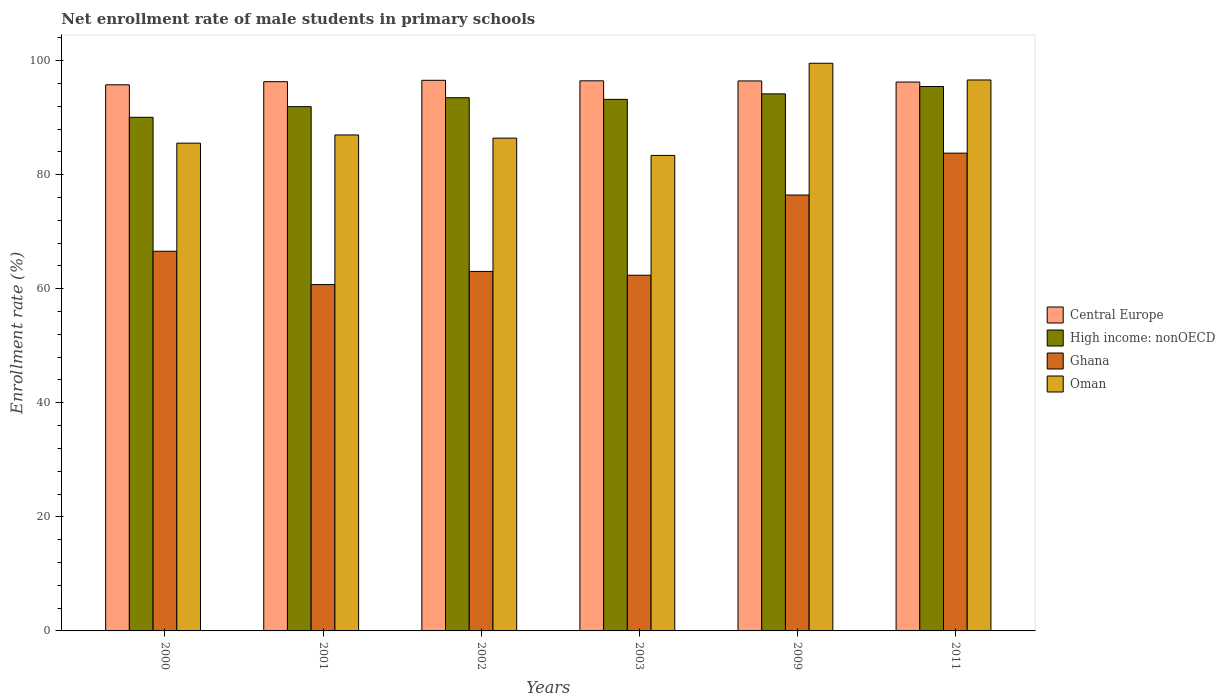How many groups of bars are there?
Your answer should be very brief. 6. How many bars are there on the 3rd tick from the left?
Make the answer very short. 4. How many bars are there on the 3rd tick from the right?
Your answer should be very brief. 4. What is the label of the 4th group of bars from the left?
Your answer should be very brief. 2003. In how many cases, is the number of bars for a given year not equal to the number of legend labels?
Provide a succinct answer. 0. What is the net enrollment rate of male students in primary schools in Central Europe in 2002?
Your answer should be compact. 96.54. Across all years, what is the maximum net enrollment rate of male students in primary schools in High income: nonOECD?
Ensure brevity in your answer.  95.45. Across all years, what is the minimum net enrollment rate of male students in primary schools in Ghana?
Your answer should be compact. 60.73. In which year was the net enrollment rate of male students in primary schools in Central Europe maximum?
Offer a very short reply. 2002. In which year was the net enrollment rate of male students in primary schools in Oman minimum?
Your answer should be compact. 2003. What is the total net enrollment rate of male students in primary schools in Central Europe in the graph?
Your response must be concise. 577.73. What is the difference between the net enrollment rate of male students in primary schools in Oman in 2002 and that in 2009?
Give a very brief answer. -13.13. What is the difference between the net enrollment rate of male students in primary schools in Oman in 2011 and the net enrollment rate of male students in primary schools in High income: nonOECD in 2009?
Offer a very short reply. 2.44. What is the average net enrollment rate of male students in primary schools in Central Europe per year?
Provide a succinct answer. 96.29. In the year 2000, what is the difference between the net enrollment rate of male students in primary schools in Central Europe and net enrollment rate of male students in primary schools in High income: nonOECD?
Offer a very short reply. 5.7. What is the ratio of the net enrollment rate of male students in primary schools in Central Europe in 2002 to that in 2009?
Ensure brevity in your answer.  1. Is the net enrollment rate of male students in primary schools in High income: nonOECD in 2002 less than that in 2003?
Make the answer very short. No. What is the difference between the highest and the second highest net enrollment rate of male students in primary schools in Ghana?
Provide a succinct answer. 7.34. What is the difference between the highest and the lowest net enrollment rate of male students in primary schools in Oman?
Provide a short and direct response. 16.16. Is the sum of the net enrollment rate of male students in primary schools in Central Europe in 2009 and 2011 greater than the maximum net enrollment rate of male students in primary schools in Oman across all years?
Offer a terse response. Yes. What does the 2nd bar from the left in 2003 represents?
Provide a short and direct response. High income: nonOECD. What does the 3rd bar from the right in 2002 represents?
Offer a very short reply. High income: nonOECD. Is it the case that in every year, the sum of the net enrollment rate of male students in primary schools in Oman and net enrollment rate of male students in primary schools in Central Europe is greater than the net enrollment rate of male students in primary schools in High income: nonOECD?
Your answer should be compact. Yes. How many bars are there?
Offer a terse response. 24. Where does the legend appear in the graph?
Ensure brevity in your answer.  Center right. How are the legend labels stacked?
Make the answer very short. Vertical. What is the title of the graph?
Offer a terse response. Net enrollment rate of male students in primary schools. What is the label or title of the Y-axis?
Keep it short and to the point. Enrollment rate (%). What is the Enrollment rate (%) of Central Europe in 2000?
Offer a very short reply. 95.75. What is the Enrollment rate (%) of High income: nonOECD in 2000?
Provide a short and direct response. 90.06. What is the Enrollment rate (%) in Ghana in 2000?
Ensure brevity in your answer.  66.57. What is the Enrollment rate (%) of Oman in 2000?
Offer a very short reply. 85.52. What is the Enrollment rate (%) of Central Europe in 2001?
Your answer should be very brief. 96.3. What is the Enrollment rate (%) of High income: nonOECD in 2001?
Offer a very short reply. 91.92. What is the Enrollment rate (%) in Ghana in 2001?
Keep it short and to the point. 60.73. What is the Enrollment rate (%) of Oman in 2001?
Your answer should be very brief. 86.96. What is the Enrollment rate (%) of Central Europe in 2002?
Offer a very short reply. 96.54. What is the Enrollment rate (%) of High income: nonOECD in 2002?
Your answer should be very brief. 93.49. What is the Enrollment rate (%) in Ghana in 2002?
Provide a short and direct response. 63.04. What is the Enrollment rate (%) of Oman in 2002?
Keep it short and to the point. 86.4. What is the Enrollment rate (%) of Central Europe in 2003?
Keep it short and to the point. 96.46. What is the Enrollment rate (%) of High income: nonOECD in 2003?
Offer a very short reply. 93.2. What is the Enrollment rate (%) of Ghana in 2003?
Provide a succinct answer. 62.37. What is the Enrollment rate (%) in Oman in 2003?
Your answer should be compact. 83.37. What is the Enrollment rate (%) in Central Europe in 2009?
Your answer should be very brief. 96.43. What is the Enrollment rate (%) in High income: nonOECD in 2009?
Your answer should be very brief. 94.17. What is the Enrollment rate (%) in Ghana in 2009?
Ensure brevity in your answer.  76.43. What is the Enrollment rate (%) in Oman in 2009?
Give a very brief answer. 99.53. What is the Enrollment rate (%) in Central Europe in 2011?
Provide a short and direct response. 96.24. What is the Enrollment rate (%) of High income: nonOECD in 2011?
Make the answer very short. 95.45. What is the Enrollment rate (%) of Ghana in 2011?
Offer a very short reply. 83.77. What is the Enrollment rate (%) of Oman in 2011?
Provide a succinct answer. 96.6. Across all years, what is the maximum Enrollment rate (%) of Central Europe?
Ensure brevity in your answer.  96.54. Across all years, what is the maximum Enrollment rate (%) in High income: nonOECD?
Your response must be concise. 95.45. Across all years, what is the maximum Enrollment rate (%) in Ghana?
Ensure brevity in your answer.  83.77. Across all years, what is the maximum Enrollment rate (%) of Oman?
Offer a very short reply. 99.53. Across all years, what is the minimum Enrollment rate (%) of Central Europe?
Keep it short and to the point. 95.75. Across all years, what is the minimum Enrollment rate (%) in High income: nonOECD?
Your answer should be very brief. 90.06. Across all years, what is the minimum Enrollment rate (%) of Ghana?
Ensure brevity in your answer.  60.73. Across all years, what is the minimum Enrollment rate (%) in Oman?
Your answer should be compact. 83.37. What is the total Enrollment rate (%) of Central Europe in the graph?
Give a very brief answer. 577.73. What is the total Enrollment rate (%) in High income: nonOECD in the graph?
Provide a short and direct response. 558.28. What is the total Enrollment rate (%) of Ghana in the graph?
Make the answer very short. 412.9. What is the total Enrollment rate (%) in Oman in the graph?
Provide a succinct answer. 538.39. What is the difference between the Enrollment rate (%) of Central Europe in 2000 and that in 2001?
Provide a short and direct response. -0.55. What is the difference between the Enrollment rate (%) of High income: nonOECD in 2000 and that in 2001?
Make the answer very short. -1.86. What is the difference between the Enrollment rate (%) in Ghana in 2000 and that in 2001?
Your response must be concise. 5.84. What is the difference between the Enrollment rate (%) of Oman in 2000 and that in 2001?
Your answer should be very brief. -1.44. What is the difference between the Enrollment rate (%) in Central Europe in 2000 and that in 2002?
Provide a short and direct response. -0.79. What is the difference between the Enrollment rate (%) of High income: nonOECD in 2000 and that in 2002?
Your response must be concise. -3.43. What is the difference between the Enrollment rate (%) in Ghana in 2000 and that in 2002?
Offer a very short reply. 3.53. What is the difference between the Enrollment rate (%) of Oman in 2000 and that in 2002?
Your answer should be compact. -0.88. What is the difference between the Enrollment rate (%) of Central Europe in 2000 and that in 2003?
Provide a short and direct response. -0.7. What is the difference between the Enrollment rate (%) in High income: nonOECD in 2000 and that in 2003?
Your response must be concise. -3.14. What is the difference between the Enrollment rate (%) in Ghana in 2000 and that in 2003?
Provide a short and direct response. 4.2. What is the difference between the Enrollment rate (%) in Oman in 2000 and that in 2003?
Your answer should be very brief. 2.15. What is the difference between the Enrollment rate (%) of Central Europe in 2000 and that in 2009?
Give a very brief answer. -0.68. What is the difference between the Enrollment rate (%) of High income: nonOECD in 2000 and that in 2009?
Offer a terse response. -4.11. What is the difference between the Enrollment rate (%) of Ghana in 2000 and that in 2009?
Give a very brief answer. -9.86. What is the difference between the Enrollment rate (%) of Oman in 2000 and that in 2009?
Keep it short and to the point. -14.01. What is the difference between the Enrollment rate (%) of Central Europe in 2000 and that in 2011?
Give a very brief answer. -0.49. What is the difference between the Enrollment rate (%) in High income: nonOECD in 2000 and that in 2011?
Offer a very short reply. -5.39. What is the difference between the Enrollment rate (%) of Ghana in 2000 and that in 2011?
Keep it short and to the point. -17.2. What is the difference between the Enrollment rate (%) in Oman in 2000 and that in 2011?
Offer a very short reply. -11.08. What is the difference between the Enrollment rate (%) of Central Europe in 2001 and that in 2002?
Provide a short and direct response. -0.24. What is the difference between the Enrollment rate (%) in High income: nonOECD in 2001 and that in 2002?
Make the answer very short. -1.57. What is the difference between the Enrollment rate (%) in Ghana in 2001 and that in 2002?
Make the answer very short. -2.31. What is the difference between the Enrollment rate (%) in Oman in 2001 and that in 2002?
Offer a very short reply. 0.56. What is the difference between the Enrollment rate (%) of Central Europe in 2001 and that in 2003?
Your response must be concise. -0.15. What is the difference between the Enrollment rate (%) in High income: nonOECD in 2001 and that in 2003?
Give a very brief answer. -1.28. What is the difference between the Enrollment rate (%) of Ghana in 2001 and that in 2003?
Offer a terse response. -1.64. What is the difference between the Enrollment rate (%) in Oman in 2001 and that in 2003?
Offer a very short reply. 3.59. What is the difference between the Enrollment rate (%) in Central Europe in 2001 and that in 2009?
Make the answer very short. -0.13. What is the difference between the Enrollment rate (%) of High income: nonOECD in 2001 and that in 2009?
Offer a very short reply. -2.24. What is the difference between the Enrollment rate (%) of Ghana in 2001 and that in 2009?
Your answer should be compact. -15.7. What is the difference between the Enrollment rate (%) of Oman in 2001 and that in 2009?
Offer a terse response. -12.57. What is the difference between the Enrollment rate (%) in Central Europe in 2001 and that in 2011?
Your answer should be compact. 0.06. What is the difference between the Enrollment rate (%) of High income: nonOECD in 2001 and that in 2011?
Your response must be concise. -3.53. What is the difference between the Enrollment rate (%) in Ghana in 2001 and that in 2011?
Your answer should be compact. -23.05. What is the difference between the Enrollment rate (%) of Oman in 2001 and that in 2011?
Ensure brevity in your answer.  -9.64. What is the difference between the Enrollment rate (%) in Central Europe in 2002 and that in 2003?
Keep it short and to the point. 0.09. What is the difference between the Enrollment rate (%) in High income: nonOECD in 2002 and that in 2003?
Offer a terse response. 0.29. What is the difference between the Enrollment rate (%) in Ghana in 2002 and that in 2003?
Ensure brevity in your answer.  0.67. What is the difference between the Enrollment rate (%) in Oman in 2002 and that in 2003?
Offer a terse response. 3.03. What is the difference between the Enrollment rate (%) in Central Europe in 2002 and that in 2009?
Give a very brief answer. 0.11. What is the difference between the Enrollment rate (%) of High income: nonOECD in 2002 and that in 2009?
Offer a very short reply. -0.68. What is the difference between the Enrollment rate (%) of Ghana in 2002 and that in 2009?
Your answer should be very brief. -13.39. What is the difference between the Enrollment rate (%) of Oman in 2002 and that in 2009?
Offer a very short reply. -13.13. What is the difference between the Enrollment rate (%) in Central Europe in 2002 and that in 2011?
Offer a very short reply. 0.3. What is the difference between the Enrollment rate (%) in High income: nonOECD in 2002 and that in 2011?
Your answer should be compact. -1.96. What is the difference between the Enrollment rate (%) in Ghana in 2002 and that in 2011?
Ensure brevity in your answer.  -20.74. What is the difference between the Enrollment rate (%) in Oman in 2002 and that in 2011?
Keep it short and to the point. -10.2. What is the difference between the Enrollment rate (%) in Central Europe in 2003 and that in 2009?
Your answer should be compact. 0.02. What is the difference between the Enrollment rate (%) in High income: nonOECD in 2003 and that in 2009?
Provide a succinct answer. -0.96. What is the difference between the Enrollment rate (%) in Ghana in 2003 and that in 2009?
Your response must be concise. -14.06. What is the difference between the Enrollment rate (%) of Oman in 2003 and that in 2009?
Offer a very short reply. -16.16. What is the difference between the Enrollment rate (%) in Central Europe in 2003 and that in 2011?
Make the answer very short. 0.22. What is the difference between the Enrollment rate (%) in High income: nonOECD in 2003 and that in 2011?
Provide a succinct answer. -2.25. What is the difference between the Enrollment rate (%) of Ghana in 2003 and that in 2011?
Your response must be concise. -21.4. What is the difference between the Enrollment rate (%) of Oman in 2003 and that in 2011?
Offer a very short reply. -13.23. What is the difference between the Enrollment rate (%) in Central Europe in 2009 and that in 2011?
Ensure brevity in your answer.  0.19. What is the difference between the Enrollment rate (%) in High income: nonOECD in 2009 and that in 2011?
Provide a succinct answer. -1.29. What is the difference between the Enrollment rate (%) in Ghana in 2009 and that in 2011?
Offer a terse response. -7.34. What is the difference between the Enrollment rate (%) of Oman in 2009 and that in 2011?
Your answer should be very brief. 2.93. What is the difference between the Enrollment rate (%) of Central Europe in 2000 and the Enrollment rate (%) of High income: nonOECD in 2001?
Offer a terse response. 3.83. What is the difference between the Enrollment rate (%) in Central Europe in 2000 and the Enrollment rate (%) in Ghana in 2001?
Provide a succinct answer. 35.03. What is the difference between the Enrollment rate (%) of Central Europe in 2000 and the Enrollment rate (%) of Oman in 2001?
Give a very brief answer. 8.79. What is the difference between the Enrollment rate (%) in High income: nonOECD in 2000 and the Enrollment rate (%) in Ghana in 2001?
Give a very brief answer. 29.33. What is the difference between the Enrollment rate (%) in High income: nonOECD in 2000 and the Enrollment rate (%) in Oman in 2001?
Give a very brief answer. 3.1. What is the difference between the Enrollment rate (%) of Ghana in 2000 and the Enrollment rate (%) of Oman in 2001?
Provide a succinct answer. -20.39. What is the difference between the Enrollment rate (%) in Central Europe in 2000 and the Enrollment rate (%) in High income: nonOECD in 2002?
Ensure brevity in your answer.  2.27. What is the difference between the Enrollment rate (%) of Central Europe in 2000 and the Enrollment rate (%) of Ghana in 2002?
Your answer should be very brief. 32.72. What is the difference between the Enrollment rate (%) in Central Europe in 2000 and the Enrollment rate (%) in Oman in 2002?
Your response must be concise. 9.35. What is the difference between the Enrollment rate (%) of High income: nonOECD in 2000 and the Enrollment rate (%) of Ghana in 2002?
Provide a succinct answer. 27.02. What is the difference between the Enrollment rate (%) of High income: nonOECD in 2000 and the Enrollment rate (%) of Oman in 2002?
Your answer should be very brief. 3.65. What is the difference between the Enrollment rate (%) of Ghana in 2000 and the Enrollment rate (%) of Oman in 2002?
Give a very brief answer. -19.84. What is the difference between the Enrollment rate (%) in Central Europe in 2000 and the Enrollment rate (%) in High income: nonOECD in 2003?
Your answer should be very brief. 2.55. What is the difference between the Enrollment rate (%) in Central Europe in 2000 and the Enrollment rate (%) in Ghana in 2003?
Give a very brief answer. 33.39. What is the difference between the Enrollment rate (%) of Central Europe in 2000 and the Enrollment rate (%) of Oman in 2003?
Your response must be concise. 12.38. What is the difference between the Enrollment rate (%) in High income: nonOECD in 2000 and the Enrollment rate (%) in Ghana in 2003?
Provide a succinct answer. 27.69. What is the difference between the Enrollment rate (%) in High income: nonOECD in 2000 and the Enrollment rate (%) in Oman in 2003?
Provide a succinct answer. 6.69. What is the difference between the Enrollment rate (%) of Ghana in 2000 and the Enrollment rate (%) of Oman in 2003?
Offer a very short reply. -16.8. What is the difference between the Enrollment rate (%) of Central Europe in 2000 and the Enrollment rate (%) of High income: nonOECD in 2009?
Make the answer very short. 1.59. What is the difference between the Enrollment rate (%) in Central Europe in 2000 and the Enrollment rate (%) in Ghana in 2009?
Offer a terse response. 19.32. What is the difference between the Enrollment rate (%) in Central Europe in 2000 and the Enrollment rate (%) in Oman in 2009?
Offer a terse response. -3.78. What is the difference between the Enrollment rate (%) of High income: nonOECD in 2000 and the Enrollment rate (%) of Ghana in 2009?
Your answer should be very brief. 13.63. What is the difference between the Enrollment rate (%) of High income: nonOECD in 2000 and the Enrollment rate (%) of Oman in 2009?
Make the answer very short. -9.48. What is the difference between the Enrollment rate (%) of Ghana in 2000 and the Enrollment rate (%) of Oman in 2009?
Provide a short and direct response. -32.96. What is the difference between the Enrollment rate (%) of Central Europe in 2000 and the Enrollment rate (%) of High income: nonOECD in 2011?
Offer a very short reply. 0.3. What is the difference between the Enrollment rate (%) of Central Europe in 2000 and the Enrollment rate (%) of Ghana in 2011?
Provide a succinct answer. 11.98. What is the difference between the Enrollment rate (%) in Central Europe in 2000 and the Enrollment rate (%) in Oman in 2011?
Your response must be concise. -0.85. What is the difference between the Enrollment rate (%) of High income: nonOECD in 2000 and the Enrollment rate (%) of Ghana in 2011?
Make the answer very short. 6.29. What is the difference between the Enrollment rate (%) in High income: nonOECD in 2000 and the Enrollment rate (%) in Oman in 2011?
Make the answer very short. -6.54. What is the difference between the Enrollment rate (%) in Ghana in 2000 and the Enrollment rate (%) in Oman in 2011?
Your response must be concise. -30.03. What is the difference between the Enrollment rate (%) in Central Europe in 2001 and the Enrollment rate (%) in High income: nonOECD in 2002?
Offer a terse response. 2.82. What is the difference between the Enrollment rate (%) in Central Europe in 2001 and the Enrollment rate (%) in Ghana in 2002?
Ensure brevity in your answer.  33.27. What is the difference between the Enrollment rate (%) in Central Europe in 2001 and the Enrollment rate (%) in Oman in 2002?
Give a very brief answer. 9.9. What is the difference between the Enrollment rate (%) of High income: nonOECD in 2001 and the Enrollment rate (%) of Ghana in 2002?
Provide a short and direct response. 28.89. What is the difference between the Enrollment rate (%) in High income: nonOECD in 2001 and the Enrollment rate (%) in Oman in 2002?
Your answer should be compact. 5.52. What is the difference between the Enrollment rate (%) of Ghana in 2001 and the Enrollment rate (%) of Oman in 2002?
Offer a very short reply. -25.68. What is the difference between the Enrollment rate (%) in Central Europe in 2001 and the Enrollment rate (%) in High income: nonOECD in 2003?
Make the answer very short. 3.1. What is the difference between the Enrollment rate (%) in Central Europe in 2001 and the Enrollment rate (%) in Ghana in 2003?
Your answer should be compact. 33.94. What is the difference between the Enrollment rate (%) of Central Europe in 2001 and the Enrollment rate (%) of Oman in 2003?
Offer a very short reply. 12.93. What is the difference between the Enrollment rate (%) of High income: nonOECD in 2001 and the Enrollment rate (%) of Ghana in 2003?
Provide a short and direct response. 29.56. What is the difference between the Enrollment rate (%) in High income: nonOECD in 2001 and the Enrollment rate (%) in Oman in 2003?
Provide a short and direct response. 8.55. What is the difference between the Enrollment rate (%) of Ghana in 2001 and the Enrollment rate (%) of Oman in 2003?
Your answer should be compact. -22.65. What is the difference between the Enrollment rate (%) in Central Europe in 2001 and the Enrollment rate (%) in High income: nonOECD in 2009?
Your answer should be very brief. 2.14. What is the difference between the Enrollment rate (%) of Central Europe in 2001 and the Enrollment rate (%) of Ghana in 2009?
Give a very brief answer. 19.87. What is the difference between the Enrollment rate (%) in Central Europe in 2001 and the Enrollment rate (%) in Oman in 2009?
Your answer should be very brief. -3.23. What is the difference between the Enrollment rate (%) of High income: nonOECD in 2001 and the Enrollment rate (%) of Ghana in 2009?
Provide a short and direct response. 15.49. What is the difference between the Enrollment rate (%) of High income: nonOECD in 2001 and the Enrollment rate (%) of Oman in 2009?
Provide a short and direct response. -7.61. What is the difference between the Enrollment rate (%) of Ghana in 2001 and the Enrollment rate (%) of Oman in 2009?
Provide a succinct answer. -38.81. What is the difference between the Enrollment rate (%) in Central Europe in 2001 and the Enrollment rate (%) in High income: nonOECD in 2011?
Ensure brevity in your answer.  0.85. What is the difference between the Enrollment rate (%) of Central Europe in 2001 and the Enrollment rate (%) of Ghana in 2011?
Your response must be concise. 12.53. What is the difference between the Enrollment rate (%) of Central Europe in 2001 and the Enrollment rate (%) of Oman in 2011?
Provide a short and direct response. -0.3. What is the difference between the Enrollment rate (%) in High income: nonOECD in 2001 and the Enrollment rate (%) in Ghana in 2011?
Your answer should be compact. 8.15. What is the difference between the Enrollment rate (%) in High income: nonOECD in 2001 and the Enrollment rate (%) in Oman in 2011?
Make the answer very short. -4.68. What is the difference between the Enrollment rate (%) in Ghana in 2001 and the Enrollment rate (%) in Oman in 2011?
Ensure brevity in your answer.  -35.88. What is the difference between the Enrollment rate (%) in Central Europe in 2002 and the Enrollment rate (%) in High income: nonOECD in 2003?
Your response must be concise. 3.34. What is the difference between the Enrollment rate (%) in Central Europe in 2002 and the Enrollment rate (%) in Ghana in 2003?
Offer a terse response. 34.18. What is the difference between the Enrollment rate (%) of Central Europe in 2002 and the Enrollment rate (%) of Oman in 2003?
Provide a succinct answer. 13.17. What is the difference between the Enrollment rate (%) of High income: nonOECD in 2002 and the Enrollment rate (%) of Ghana in 2003?
Make the answer very short. 31.12. What is the difference between the Enrollment rate (%) in High income: nonOECD in 2002 and the Enrollment rate (%) in Oman in 2003?
Offer a very short reply. 10.12. What is the difference between the Enrollment rate (%) of Ghana in 2002 and the Enrollment rate (%) of Oman in 2003?
Offer a terse response. -20.34. What is the difference between the Enrollment rate (%) of Central Europe in 2002 and the Enrollment rate (%) of High income: nonOECD in 2009?
Your response must be concise. 2.38. What is the difference between the Enrollment rate (%) in Central Europe in 2002 and the Enrollment rate (%) in Ghana in 2009?
Provide a succinct answer. 20.11. What is the difference between the Enrollment rate (%) of Central Europe in 2002 and the Enrollment rate (%) of Oman in 2009?
Your answer should be very brief. -2.99. What is the difference between the Enrollment rate (%) of High income: nonOECD in 2002 and the Enrollment rate (%) of Ghana in 2009?
Your answer should be very brief. 17.06. What is the difference between the Enrollment rate (%) of High income: nonOECD in 2002 and the Enrollment rate (%) of Oman in 2009?
Provide a short and direct response. -6.04. What is the difference between the Enrollment rate (%) of Ghana in 2002 and the Enrollment rate (%) of Oman in 2009?
Your answer should be compact. -36.5. What is the difference between the Enrollment rate (%) of Central Europe in 2002 and the Enrollment rate (%) of High income: nonOECD in 2011?
Offer a very short reply. 1.09. What is the difference between the Enrollment rate (%) of Central Europe in 2002 and the Enrollment rate (%) of Ghana in 2011?
Offer a very short reply. 12.77. What is the difference between the Enrollment rate (%) of Central Europe in 2002 and the Enrollment rate (%) of Oman in 2011?
Make the answer very short. -0.06. What is the difference between the Enrollment rate (%) of High income: nonOECD in 2002 and the Enrollment rate (%) of Ghana in 2011?
Make the answer very short. 9.72. What is the difference between the Enrollment rate (%) in High income: nonOECD in 2002 and the Enrollment rate (%) in Oman in 2011?
Provide a succinct answer. -3.11. What is the difference between the Enrollment rate (%) in Ghana in 2002 and the Enrollment rate (%) in Oman in 2011?
Provide a short and direct response. -33.57. What is the difference between the Enrollment rate (%) in Central Europe in 2003 and the Enrollment rate (%) in High income: nonOECD in 2009?
Your response must be concise. 2.29. What is the difference between the Enrollment rate (%) of Central Europe in 2003 and the Enrollment rate (%) of Ghana in 2009?
Provide a short and direct response. 20.03. What is the difference between the Enrollment rate (%) of Central Europe in 2003 and the Enrollment rate (%) of Oman in 2009?
Keep it short and to the point. -3.08. What is the difference between the Enrollment rate (%) of High income: nonOECD in 2003 and the Enrollment rate (%) of Ghana in 2009?
Ensure brevity in your answer.  16.77. What is the difference between the Enrollment rate (%) of High income: nonOECD in 2003 and the Enrollment rate (%) of Oman in 2009?
Provide a short and direct response. -6.33. What is the difference between the Enrollment rate (%) in Ghana in 2003 and the Enrollment rate (%) in Oman in 2009?
Offer a very short reply. -37.17. What is the difference between the Enrollment rate (%) of Central Europe in 2003 and the Enrollment rate (%) of Ghana in 2011?
Offer a very short reply. 12.69. What is the difference between the Enrollment rate (%) of Central Europe in 2003 and the Enrollment rate (%) of Oman in 2011?
Make the answer very short. -0.15. What is the difference between the Enrollment rate (%) in High income: nonOECD in 2003 and the Enrollment rate (%) in Ghana in 2011?
Provide a short and direct response. 9.43. What is the difference between the Enrollment rate (%) of High income: nonOECD in 2003 and the Enrollment rate (%) of Oman in 2011?
Your answer should be compact. -3.4. What is the difference between the Enrollment rate (%) in Ghana in 2003 and the Enrollment rate (%) in Oman in 2011?
Offer a terse response. -34.23. What is the difference between the Enrollment rate (%) in Central Europe in 2009 and the Enrollment rate (%) in High income: nonOECD in 2011?
Keep it short and to the point. 0.98. What is the difference between the Enrollment rate (%) of Central Europe in 2009 and the Enrollment rate (%) of Ghana in 2011?
Provide a short and direct response. 12.66. What is the difference between the Enrollment rate (%) in Central Europe in 2009 and the Enrollment rate (%) in Oman in 2011?
Offer a very short reply. -0.17. What is the difference between the Enrollment rate (%) of High income: nonOECD in 2009 and the Enrollment rate (%) of Ghana in 2011?
Your response must be concise. 10.39. What is the difference between the Enrollment rate (%) of High income: nonOECD in 2009 and the Enrollment rate (%) of Oman in 2011?
Provide a succinct answer. -2.44. What is the difference between the Enrollment rate (%) in Ghana in 2009 and the Enrollment rate (%) in Oman in 2011?
Offer a terse response. -20.17. What is the average Enrollment rate (%) of Central Europe per year?
Keep it short and to the point. 96.29. What is the average Enrollment rate (%) of High income: nonOECD per year?
Provide a succinct answer. 93.05. What is the average Enrollment rate (%) of Ghana per year?
Your answer should be compact. 68.82. What is the average Enrollment rate (%) of Oman per year?
Your answer should be very brief. 89.73. In the year 2000, what is the difference between the Enrollment rate (%) in Central Europe and Enrollment rate (%) in High income: nonOECD?
Your response must be concise. 5.7. In the year 2000, what is the difference between the Enrollment rate (%) of Central Europe and Enrollment rate (%) of Ghana?
Offer a terse response. 29.18. In the year 2000, what is the difference between the Enrollment rate (%) in Central Europe and Enrollment rate (%) in Oman?
Ensure brevity in your answer.  10.23. In the year 2000, what is the difference between the Enrollment rate (%) of High income: nonOECD and Enrollment rate (%) of Ghana?
Provide a succinct answer. 23.49. In the year 2000, what is the difference between the Enrollment rate (%) of High income: nonOECD and Enrollment rate (%) of Oman?
Your answer should be compact. 4.53. In the year 2000, what is the difference between the Enrollment rate (%) of Ghana and Enrollment rate (%) of Oman?
Provide a succinct answer. -18.96. In the year 2001, what is the difference between the Enrollment rate (%) of Central Europe and Enrollment rate (%) of High income: nonOECD?
Offer a very short reply. 4.38. In the year 2001, what is the difference between the Enrollment rate (%) in Central Europe and Enrollment rate (%) in Ghana?
Offer a very short reply. 35.58. In the year 2001, what is the difference between the Enrollment rate (%) of Central Europe and Enrollment rate (%) of Oman?
Offer a very short reply. 9.34. In the year 2001, what is the difference between the Enrollment rate (%) of High income: nonOECD and Enrollment rate (%) of Ghana?
Offer a very short reply. 31.2. In the year 2001, what is the difference between the Enrollment rate (%) of High income: nonOECD and Enrollment rate (%) of Oman?
Your response must be concise. 4.96. In the year 2001, what is the difference between the Enrollment rate (%) in Ghana and Enrollment rate (%) in Oman?
Your answer should be compact. -26.23. In the year 2002, what is the difference between the Enrollment rate (%) of Central Europe and Enrollment rate (%) of High income: nonOECD?
Make the answer very short. 3.06. In the year 2002, what is the difference between the Enrollment rate (%) in Central Europe and Enrollment rate (%) in Ghana?
Your answer should be very brief. 33.51. In the year 2002, what is the difference between the Enrollment rate (%) of Central Europe and Enrollment rate (%) of Oman?
Your response must be concise. 10.14. In the year 2002, what is the difference between the Enrollment rate (%) of High income: nonOECD and Enrollment rate (%) of Ghana?
Your answer should be compact. 30.45. In the year 2002, what is the difference between the Enrollment rate (%) of High income: nonOECD and Enrollment rate (%) of Oman?
Provide a succinct answer. 7.08. In the year 2002, what is the difference between the Enrollment rate (%) in Ghana and Enrollment rate (%) in Oman?
Provide a short and direct response. -23.37. In the year 2003, what is the difference between the Enrollment rate (%) of Central Europe and Enrollment rate (%) of High income: nonOECD?
Your answer should be compact. 3.26. In the year 2003, what is the difference between the Enrollment rate (%) in Central Europe and Enrollment rate (%) in Ghana?
Give a very brief answer. 34.09. In the year 2003, what is the difference between the Enrollment rate (%) in Central Europe and Enrollment rate (%) in Oman?
Your response must be concise. 13.08. In the year 2003, what is the difference between the Enrollment rate (%) of High income: nonOECD and Enrollment rate (%) of Ghana?
Provide a short and direct response. 30.83. In the year 2003, what is the difference between the Enrollment rate (%) in High income: nonOECD and Enrollment rate (%) in Oman?
Offer a terse response. 9.83. In the year 2003, what is the difference between the Enrollment rate (%) in Ghana and Enrollment rate (%) in Oman?
Provide a short and direct response. -21.01. In the year 2009, what is the difference between the Enrollment rate (%) of Central Europe and Enrollment rate (%) of High income: nonOECD?
Offer a terse response. 2.27. In the year 2009, what is the difference between the Enrollment rate (%) in Central Europe and Enrollment rate (%) in Ghana?
Your answer should be very brief. 20. In the year 2009, what is the difference between the Enrollment rate (%) in Central Europe and Enrollment rate (%) in Oman?
Ensure brevity in your answer.  -3.1. In the year 2009, what is the difference between the Enrollment rate (%) in High income: nonOECD and Enrollment rate (%) in Ghana?
Give a very brief answer. 17.74. In the year 2009, what is the difference between the Enrollment rate (%) in High income: nonOECD and Enrollment rate (%) in Oman?
Provide a short and direct response. -5.37. In the year 2009, what is the difference between the Enrollment rate (%) of Ghana and Enrollment rate (%) of Oman?
Your answer should be compact. -23.1. In the year 2011, what is the difference between the Enrollment rate (%) in Central Europe and Enrollment rate (%) in High income: nonOECD?
Your response must be concise. 0.79. In the year 2011, what is the difference between the Enrollment rate (%) in Central Europe and Enrollment rate (%) in Ghana?
Make the answer very short. 12.47. In the year 2011, what is the difference between the Enrollment rate (%) of Central Europe and Enrollment rate (%) of Oman?
Offer a very short reply. -0.36. In the year 2011, what is the difference between the Enrollment rate (%) of High income: nonOECD and Enrollment rate (%) of Ghana?
Provide a succinct answer. 11.68. In the year 2011, what is the difference between the Enrollment rate (%) of High income: nonOECD and Enrollment rate (%) of Oman?
Offer a very short reply. -1.15. In the year 2011, what is the difference between the Enrollment rate (%) of Ghana and Enrollment rate (%) of Oman?
Offer a terse response. -12.83. What is the ratio of the Enrollment rate (%) of High income: nonOECD in 2000 to that in 2001?
Provide a succinct answer. 0.98. What is the ratio of the Enrollment rate (%) of Ghana in 2000 to that in 2001?
Offer a very short reply. 1.1. What is the ratio of the Enrollment rate (%) of Oman in 2000 to that in 2001?
Provide a short and direct response. 0.98. What is the ratio of the Enrollment rate (%) of Central Europe in 2000 to that in 2002?
Offer a terse response. 0.99. What is the ratio of the Enrollment rate (%) of High income: nonOECD in 2000 to that in 2002?
Provide a succinct answer. 0.96. What is the ratio of the Enrollment rate (%) in Ghana in 2000 to that in 2002?
Your answer should be very brief. 1.06. What is the ratio of the Enrollment rate (%) in Central Europe in 2000 to that in 2003?
Ensure brevity in your answer.  0.99. What is the ratio of the Enrollment rate (%) of High income: nonOECD in 2000 to that in 2003?
Give a very brief answer. 0.97. What is the ratio of the Enrollment rate (%) of Ghana in 2000 to that in 2003?
Your answer should be very brief. 1.07. What is the ratio of the Enrollment rate (%) in Oman in 2000 to that in 2003?
Offer a terse response. 1.03. What is the ratio of the Enrollment rate (%) of Central Europe in 2000 to that in 2009?
Keep it short and to the point. 0.99. What is the ratio of the Enrollment rate (%) of High income: nonOECD in 2000 to that in 2009?
Offer a very short reply. 0.96. What is the ratio of the Enrollment rate (%) in Ghana in 2000 to that in 2009?
Provide a succinct answer. 0.87. What is the ratio of the Enrollment rate (%) of Oman in 2000 to that in 2009?
Keep it short and to the point. 0.86. What is the ratio of the Enrollment rate (%) in Central Europe in 2000 to that in 2011?
Provide a succinct answer. 0.99. What is the ratio of the Enrollment rate (%) of High income: nonOECD in 2000 to that in 2011?
Offer a terse response. 0.94. What is the ratio of the Enrollment rate (%) of Ghana in 2000 to that in 2011?
Your answer should be very brief. 0.79. What is the ratio of the Enrollment rate (%) in Oman in 2000 to that in 2011?
Your response must be concise. 0.89. What is the ratio of the Enrollment rate (%) in High income: nonOECD in 2001 to that in 2002?
Offer a terse response. 0.98. What is the ratio of the Enrollment rate (%) in Ghana in 2001 to that in 2002?
Ensure brevity in your answer.  0.96. What is the ratio of the Enrollment rate (%) of Oman in 2001 to that in 2002?
Keep it short and to the point. 1.01. What is the ratio of the Enrollment rate (%) of High income: nonOECD in 2001 to that in 2003?
Provide a succinct answer. 0.99. What is the ratio of the Enrollment rate (%) in Ghana in 2001 to that in 2003?
Your response must be concise. 0.97. What is the ratio of the Enrollment rate (%) of Oman in 2001 to that in 2003?
Your answer should be compact. 1.04. What is the ratio of the Enrollment rate (%) of Central Europe in 2001 to that in 2009?
Your answer should be very brief. 1. What is the ratio of the Enrollment rate (%) in High income: nonOECD in 2001 to that in 2009?
Your response must be concise. 0.98. What is the ratio of the Enrollment rate (%) of Ghana in 2001 to that in 2009?
Provide a short and direct response. 0.79. What is the ratio of the Enrollment rate (%) in Oman in 2001 to that in 2009?
Make the answer very short. 0.87. What is the ratio of the Enrollment rate (%) in Central Europe in 2001 to that in 2011?
Provide a succinct answer. 1. What is the ratio of the Enrollment rate (%) in High income: nonOECD in 2001 to that in 2011?
Give a very brief answer. 0.96. What is the ratio of the Enrollment rate (%) in Ghana in 2001 to that in 2011?
Offer a very short reply. 0.72. What is the ratio of the Enrollment rate (%) of Oman in 2001 to that in 2011?
Your response must be concise. 0.9. What is the ratio of the Enrollment rate (%) of Ghana in 2002 to that in 2003?
Provide a short and direct response. 1.01. What is the ratio of the Enrollment rate (%) of Oman in 2002 to that in 2003?
Offer a very short reply. 1.04. What is the ratio of the Enrollment rate (%) of Ghana in 2002 to that in 2009?
Provide a succinct answer. 0.82. What is the ratio of the Enrollment rate (%) in Oman in 2002 to that in 2009?
Ensure brevity in your answer.  0.87. What is the ratio of the Enrollment rate (%) of Central Europe in 2002 to that in 2011?
Provide a succinct answer. 1. What is the ratio of the Enrollment rate (%) of High income: nonOECD in 2002 to that in 2011?
Provide a short and direct response. 0.98. What is the ratio of the Enrollment rate (%) in Ghana in 2002 to that in 2011?
Offer a very short reply. 0.75. What is the ratio of the Enrollment rate (%) of Oman in 2002 to that in 2011?
Your answer should be compact. 0.89. What is the ratio of the Enrollment rate (%) of Central Europe in 2003 to that in 2009?
Give a very brief answer. 1. What is the ratio of the Enrollment rate (%) of High income: nonOECD in 2003 to that in 2009?
Your answer should be compact. 0.99. What is the ratio of the Enrollment rate (%) of Ghana in 2003 to that in 2009?
Your response must be concise. 0.82. What is the ratio of the Enrollment rate (%) of Oman in 2003 to that in 2009?
Give a very brief answer. 0.84. What is the ratio of the Enrollment rate (%) of High income: nonOECD in 2003 to that in 2011?
Your answer should be compact. 0.98. What is the ratio of the Enrollment rate (%) of Ghana in 2003 to that in 2011?
Ensure brevity in your answer.  0.74. What is the ratio of the Enrollment rate (%) in Oman in 2003 to that in 2011?
Provide a succinct answer. 0.86. What is the ratio of the Enrollment rate (%) in High income: nonOECD in 2009 to that in 2011?
Ensure brevity in your answer.  0.99. What is the ratio of the Enrollment rate (%) of Ghana in 2009 to that in 2011?
Your response must be concise. 0.91. What is the ratio of the Enrollment rate (%) in Oman in 2009 to that in 2011?
Your answer should be compact. 1.03. What is the difference between the highest and the second highest Enrollment rate (%) of Central Europe?
Ensure brevity in your answer.  0.09. What is the difference between the highest and the second highest Enrollment rate (%) of High income: nonOECD?
Provide a succinct answer. 1.29. What is the difference between the highest and the second highest Enrollment rate (%) of Ghana?
Offer a terse response. 7.34. What is the difference between the highest and the second highest Enrollment rate (%) in Oman?
Keep it short and to the point. 2.93. What is the difference between the highest and the lowest Enrollment rate (%) of Central Europe?
Offer a terse response. 0.79. What is the difference between the highest and the lowest Enrollment rate (%) in High income: nonOECD?
Ensure brevity in your answer.  5.39. What is the difference between the highest and the lowest Enrollment rate (%) of Ghana?
Give a very brief answer. 23.05. What is the difference between the highest and the lowest Enrollment rate (%) in Oman?
Provide a short and direct response. 16.16. 